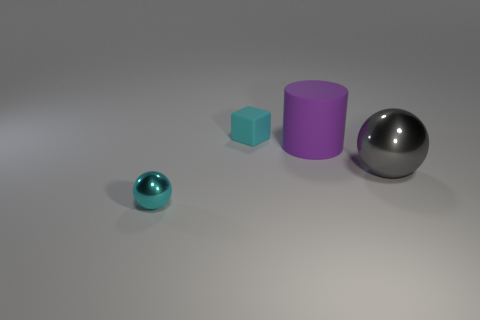Add 3 big yellow cubes. How many objects exist? 7 Subtract all cyan spheres. How many spheres are left? 1 Subtract all blocks. How many objects are left? 3 Subtract all purple blocks. How many cyan spheres are left? 1 Subtract all cyan spheres. Subtract all cyan rubber objects. How many objects are left? 2 Add 1 large purple things. How many large purple things are left? 2 Add 4 cyan matte objects. How many cyan matte objects exist? 5 Subtract 0 cyan cylinders. How many objects are left? 4 Subtract all brown cylinders. Subtract all cyan balls. How many cylinders are left? 1 